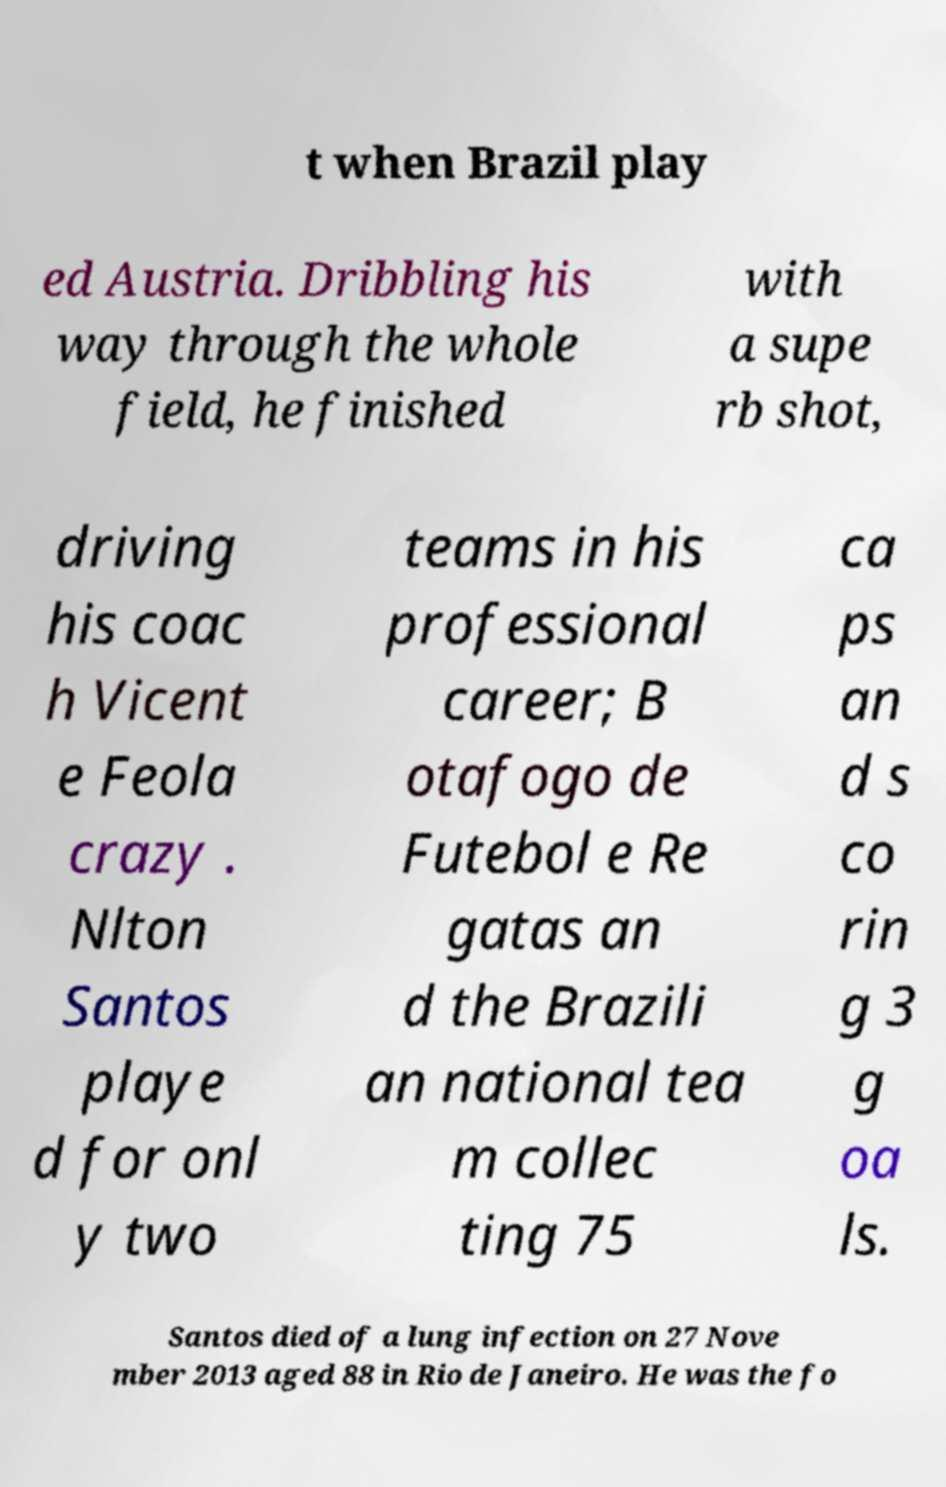Could you assist in decoding the text presented in this image and type it out clearly? t when Brazil play ed Austria. Dribbling his way through the whole field, he finished with a supe rb shot, driving his coac h Vicent e Feola crazy . Nlton Santos playe d for onl y two teams in his professional career; B otafogo de Futebol e Re gatas an d the Brazili an national tea m collec ting 75 ca ps an d s co rin g 3 g oa ls. Santos died of a lung infection on 27 Nove mber 2013 aged 88 in Rio de Janeiro. He was the fo 